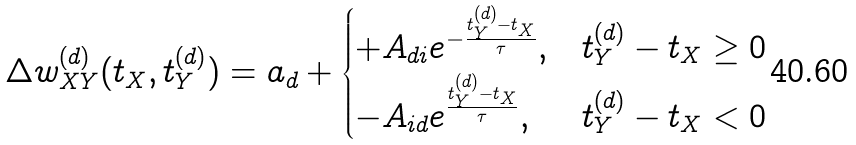<formula> <loc_0><loc_0><loc_500><loc_500>\Delta w _ { X Y } ^ { ( d ) } ( t _ { X } , t _ { Y } ^ { ( d ) } ) = a _ { d } + \begin{cases} + A _ { d i } e ^ { - \frac { t _ { Y } ^ { ( d ) } - t _ { X } } { \tau } } , & t _ { Y } ^ { ( d ) } - t _ { X } \geq 0 \\ - A _ { i d } e ^ { \frac { t _ { Y } ^ { ( d ) } - t _ { X } } { \tau } } , & t _ { Y } ^ { ( d ) } - t _ { X } < 0 \end{cases}</formula> 